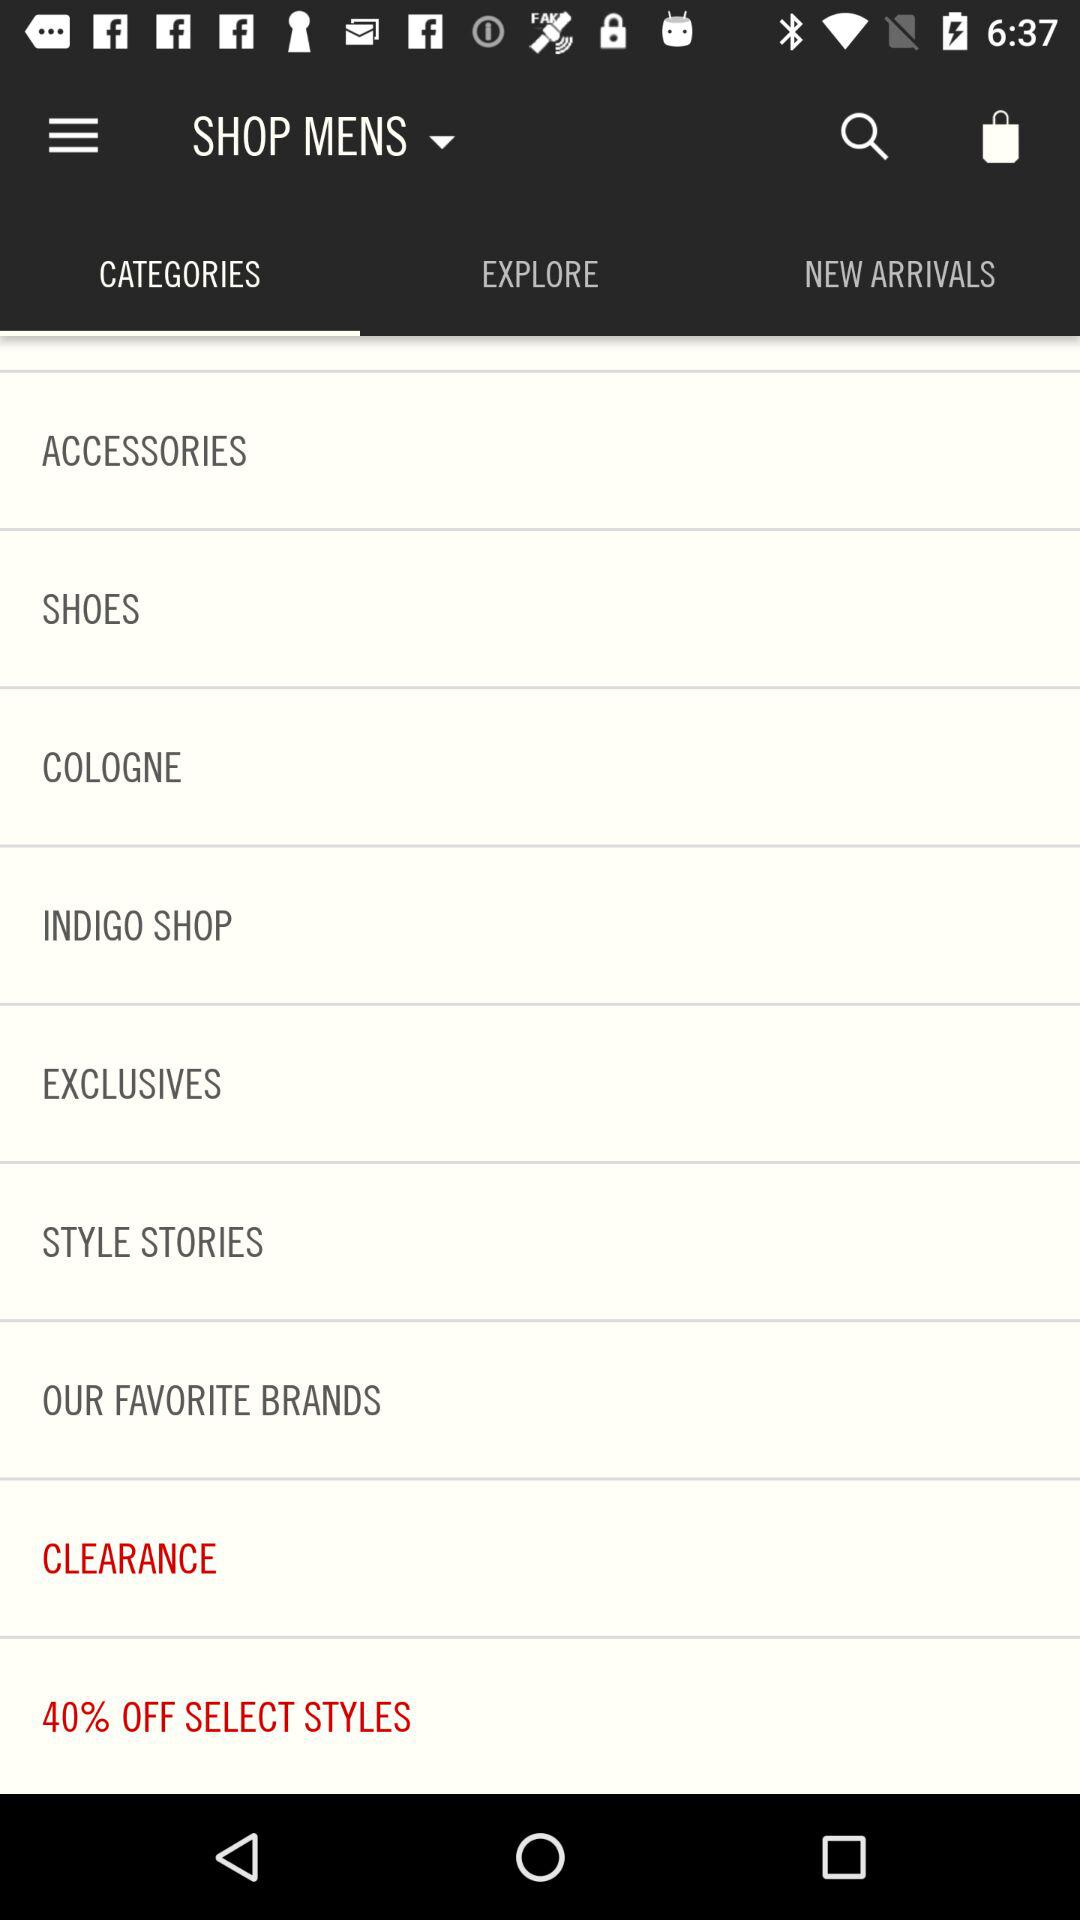Which tab is selected? The selected tab is "CATEGORIES". 